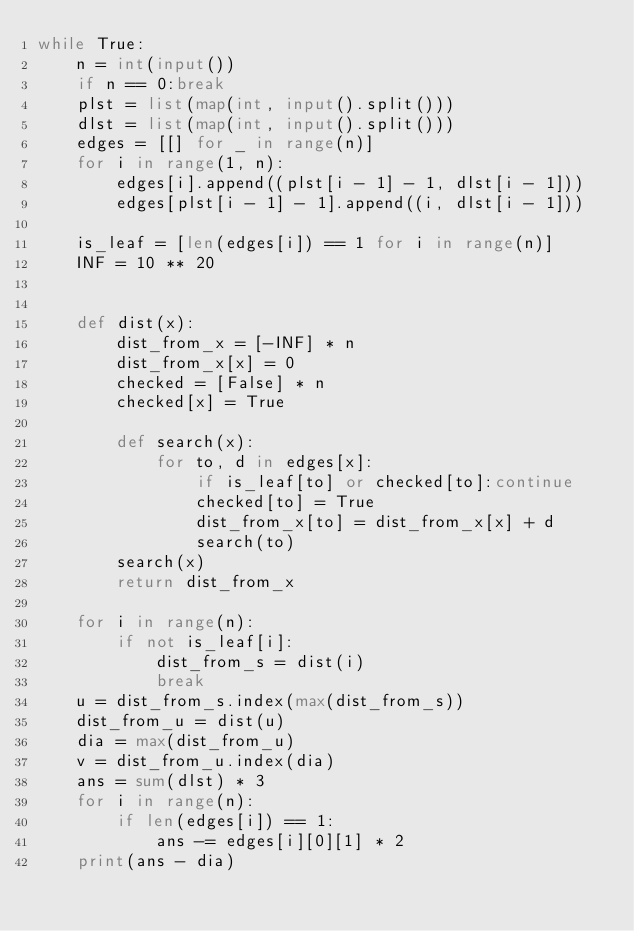<code> <loc_0><loc_0><loc_500><loc_500><_Python_>while True:
    n = int(input())
    if n == 0:break
    plst = list(map(int, input().split()))
    dlst = list(map(int, input().split()))
    edges = [[] for _ in range(n)]
    for i in range(1, n):
        edges[i].append((plst[i - 1] - 1, dlst[i - 1]))
        edges[plst[i - 1] - 1].append((i, dlst[i - 1]))

    is_leaf = [len(edges[i]) == 1 for i in range(n)]
    INF = 10 ** 20


    def dist(x):
        dist_from_x = [-INF] * n
        dist_from_x[x] = 0
        checked = [False] * n
        checked[x] = True

        def search(x):
            for to, d in edges[x]:
                if is_leaf[to] or checked[to]:continue
                checked[to] = True
                dist_from_x[to] = dist_from_x[x] + d
                search(to)
        search(x)
        return dist_from_x

    for i in range(n):
        if not is_leaf[i]:
            dist_from_s = dist(i)
            break
    u = dist_from_s.index(max(dist_from_s))
    dist_from_u = dist(u)
    dia = max(dist_from_u)
    v = dist_from_u.index(dia)
    ans = sum(dlst) * 3
    for i in range(n):
        if len(edges[i]) == 1:
            ans -= edges[i][0][1] * 2
    print(ans - dia)
</code> 